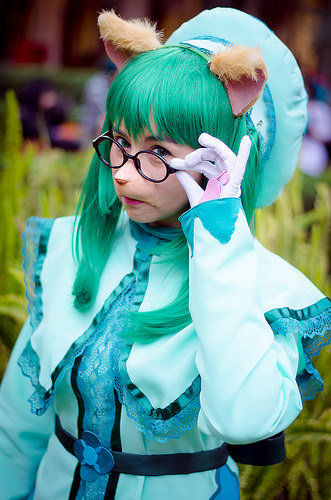<image>
Can you confirm if the plants is next to the woman? Yes. The plants is positioned adjacent to the woman, located nearby in the same general area. 